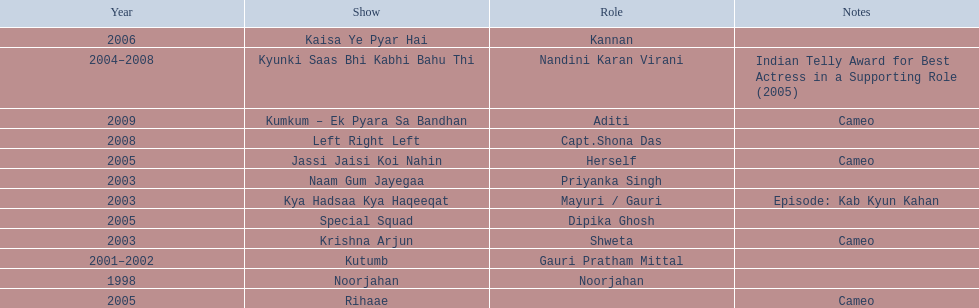On what shows did gauri pradhan tejwani appear after 2000? Kutumb, Krishna Arjun, Naam Gum Jayegaa, Kya Hadsaa Kya Haqeeqat, Kyunki Saas Bhi Kabhi Bahu Thi, Rihaae, Jassi Jaisi Koi Nahin, Special Squad, Kaisa Ye Pyar Hai, Left Right Left, Kumkum – Ek Pyara Sa Bandhan. In which of them was is a cameo appearance? Krishna Arjun, Rihaae, Jassi Jaisi Koi Nahin, Kumkum – Ek Pyara Sa Bandhan. Of these which one did she play the role of herself? Jassi Jaisi Koi Nahin. 